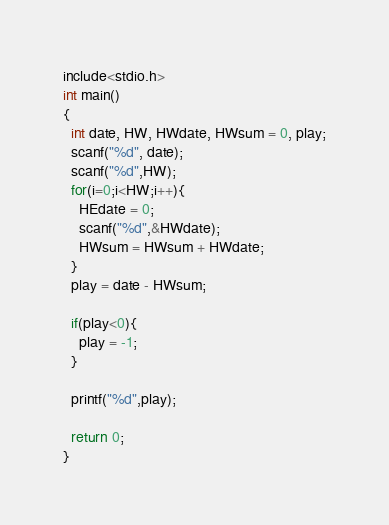<code> <loc_0><loc_0><loc_500><loc_500><_C_>include<stdio.h>
int main()
{
  int date, HW, HWdate, HWsum = 0, play;
  scanf("%d", date);
  scanf("%d",HW);
  for(i=0;i<HW;i++){
    HEdate = 0;
    scanf("%d",&HWdate);
    HWsum = HWsum + HWdate;
  }
  play = date - HWsum;
  
  if(play<0){
    play = -1;
  }

  printf("%d",play);
  
  return 0;
}</code> 